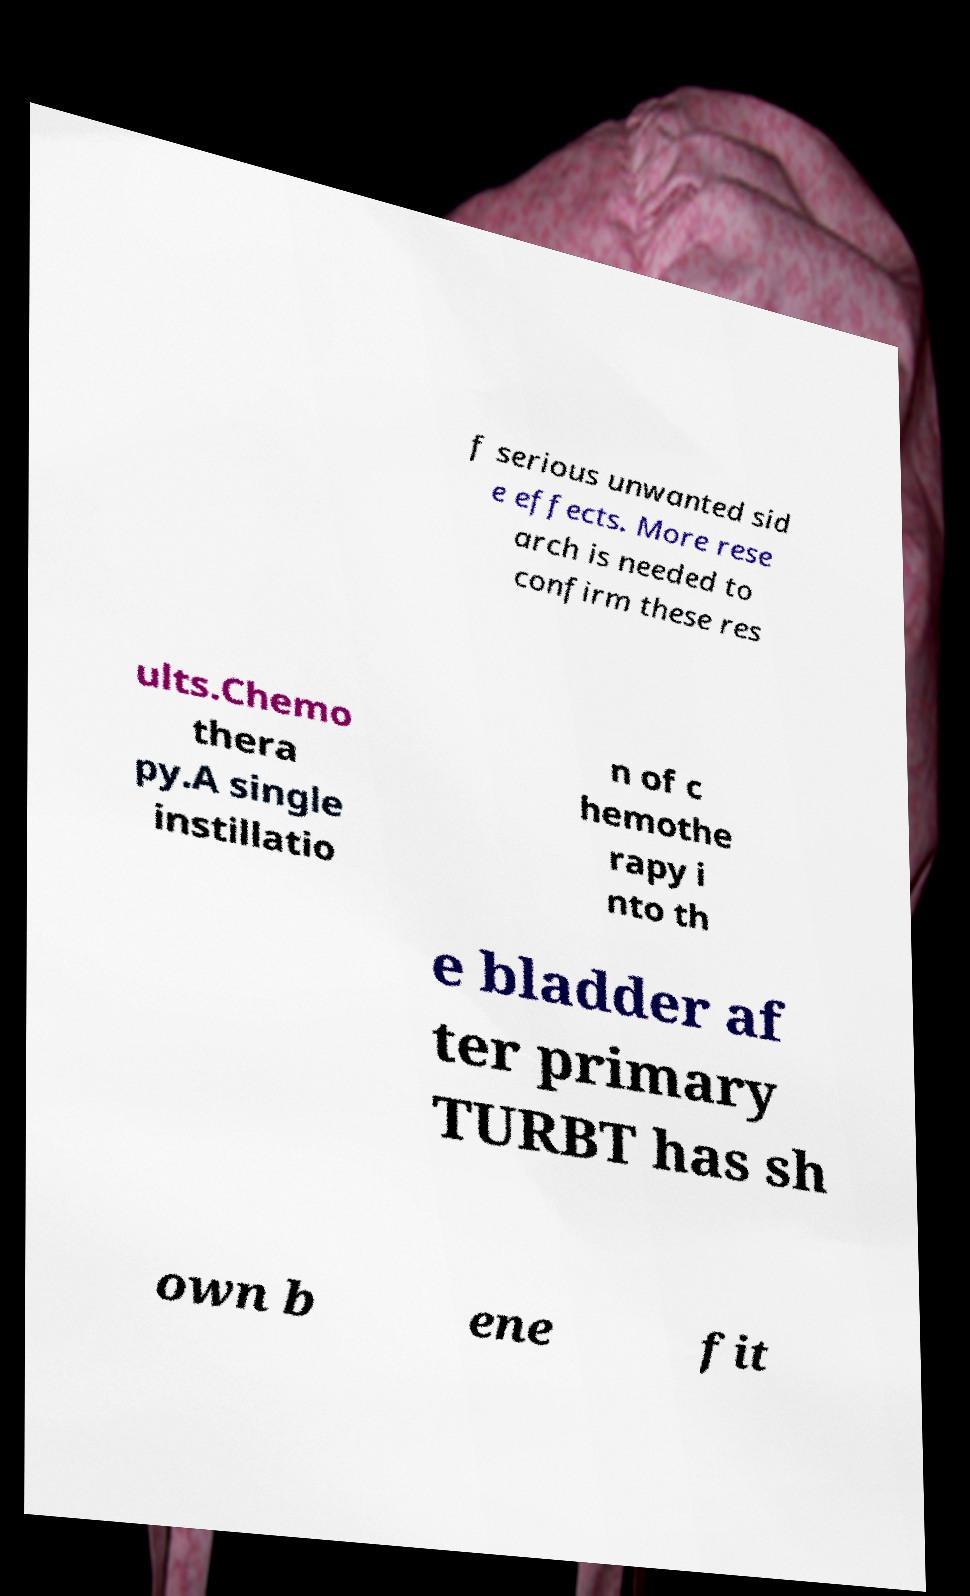Could you assist in decoding the text presented in this image and type it out clearly? f serious unwanted sid e effects. More rese arch is needed to confirm these res ults.Chemo thera py.A single instillatio n of c hemothe rapy i nto th e bladder af ter primary TURBT has sh own b ene fit 